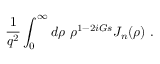Convert formula to latex. <formula><loc_0><loc_0><loc_500><loc_500>{ \frac { 1 } { q ^ { 2 } } } \int _ { 0 } ^ { \infty } d \rho \rho ^ { 1 - 2 i G s } J _ { n } ( \rho ) .</formula> 